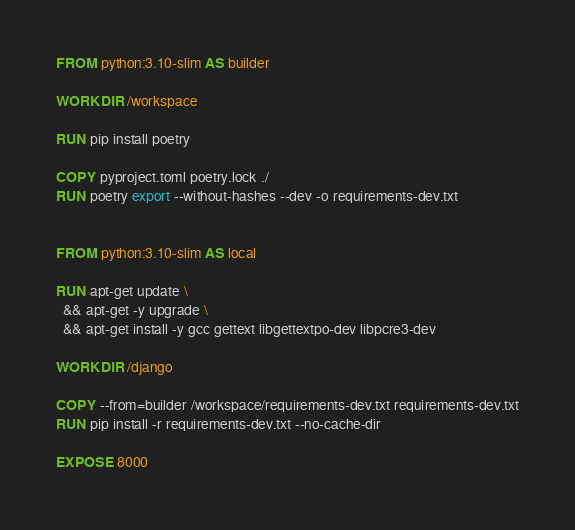<code> <loc_0><loc_0><loc_500><loc_500><_Dockerfile_>FROM python:3.10-slim AS builder

WORKDIR /workspace

RUN pip install poetry

COPY pyproject.toml poetry.lock ./
RUN poetry export --without-hashes --dev -o requirements-dev.txt


FROM python:3.10-slim AS local

RUN apt-get update \
  && apt-get -y upgrade \
  && apt-get install -y gcc gettext libgettextpo-dev libpcre3-dev

WORKDIR /django

COPY --from=builder /workspace/requirements-dev.txt requirements-dev.txt
RUN pip install -r requirements-dev.txt --no-cache-dir

EXPOSE 8000
</code> 